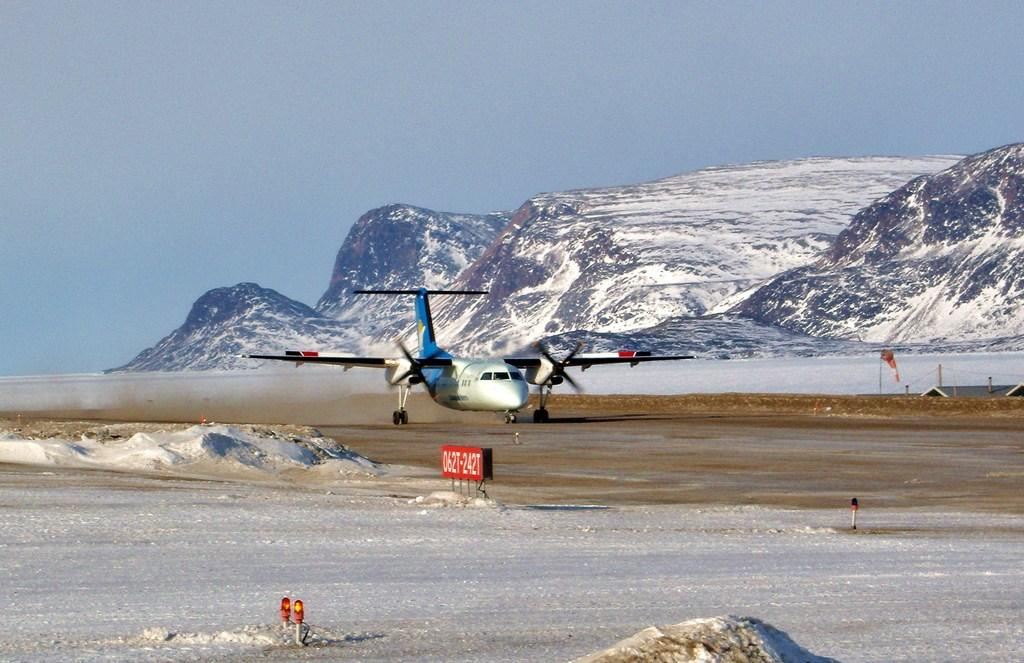What is located on the runway in the image? There is an airplane on the runway in the image. What can be seen in the image besides the airplane? There are lights, snow, a tent, snow mountains in the background, and sky visible in the background. What type of weather is depicted in the image? The presence of snow suggests that it is a snowy or wintery scene. What is the background of the image? The background of the image includes snow mountains and sky. What type of quiver can be seen hanging from the airplane in the image? There is no quiver present in the image; it features an airplane on a runway with snow, lights, a tent, snow mountains, and sky. Can you tell me how many guns are visible in the image? There are no guns visible in the image; it features an airplane on a runway with snow, lights, a tent, snow mountains, and sky. 